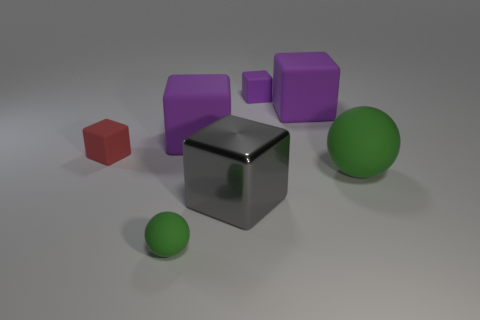What materials do the objects in the image seem to be made of? The objects in the image give the impression of being made of different materials. The small red cube looks like it could be a matte plastic, while the large reflective cube might be a polished metal. The purple cubes appear to have a slightly less reflective plastic surface, and the spheres look like they could be made of a smooth, matte material. 